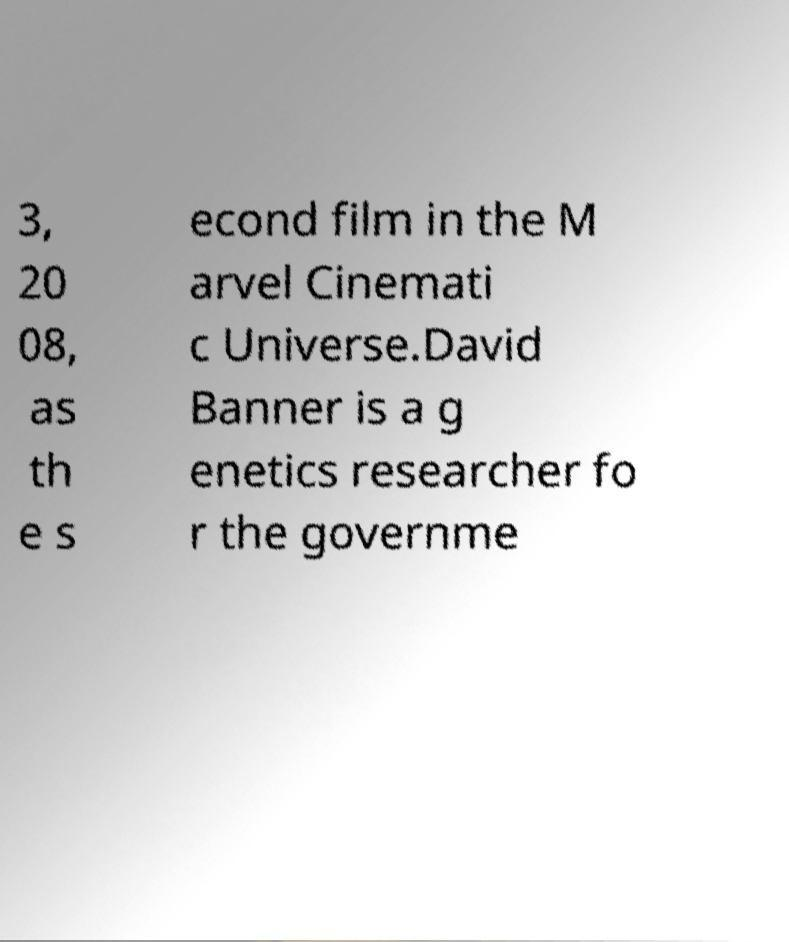Please identify and transcribe the text found in this image. 3, 20 08, as th e s econd film in the M arvel Cinemati c Universe.David Banner is a g enetics researcher fo r the governme 